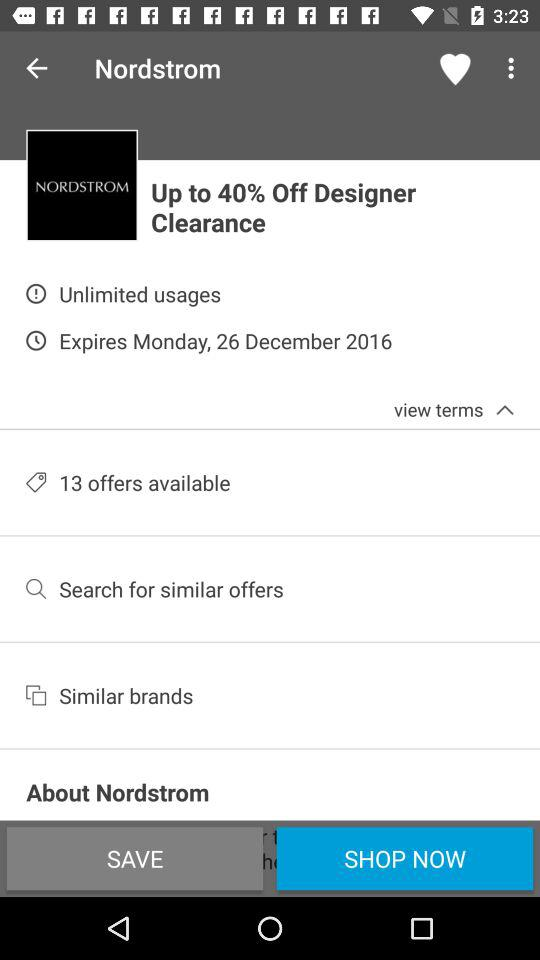How many offers are available?
Answer the question using a single word or phrase. 13 